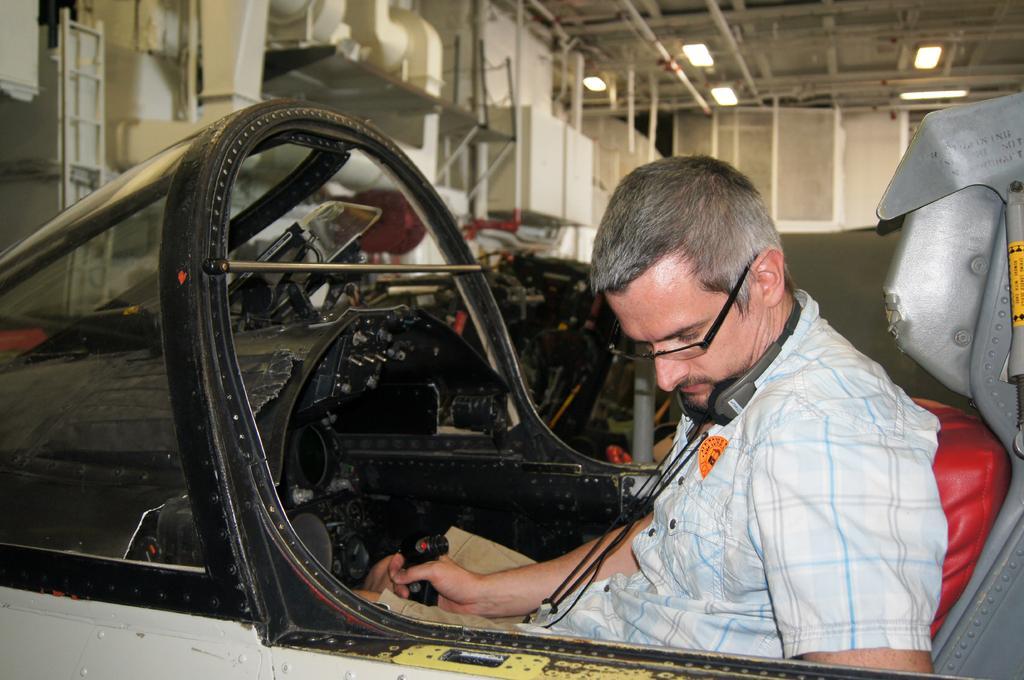Please provide a concise description of this image. In this image, we can see a person is sitting inside the vehicle and holding a black object. Background we can see lights, rods, pipes and few objects. 